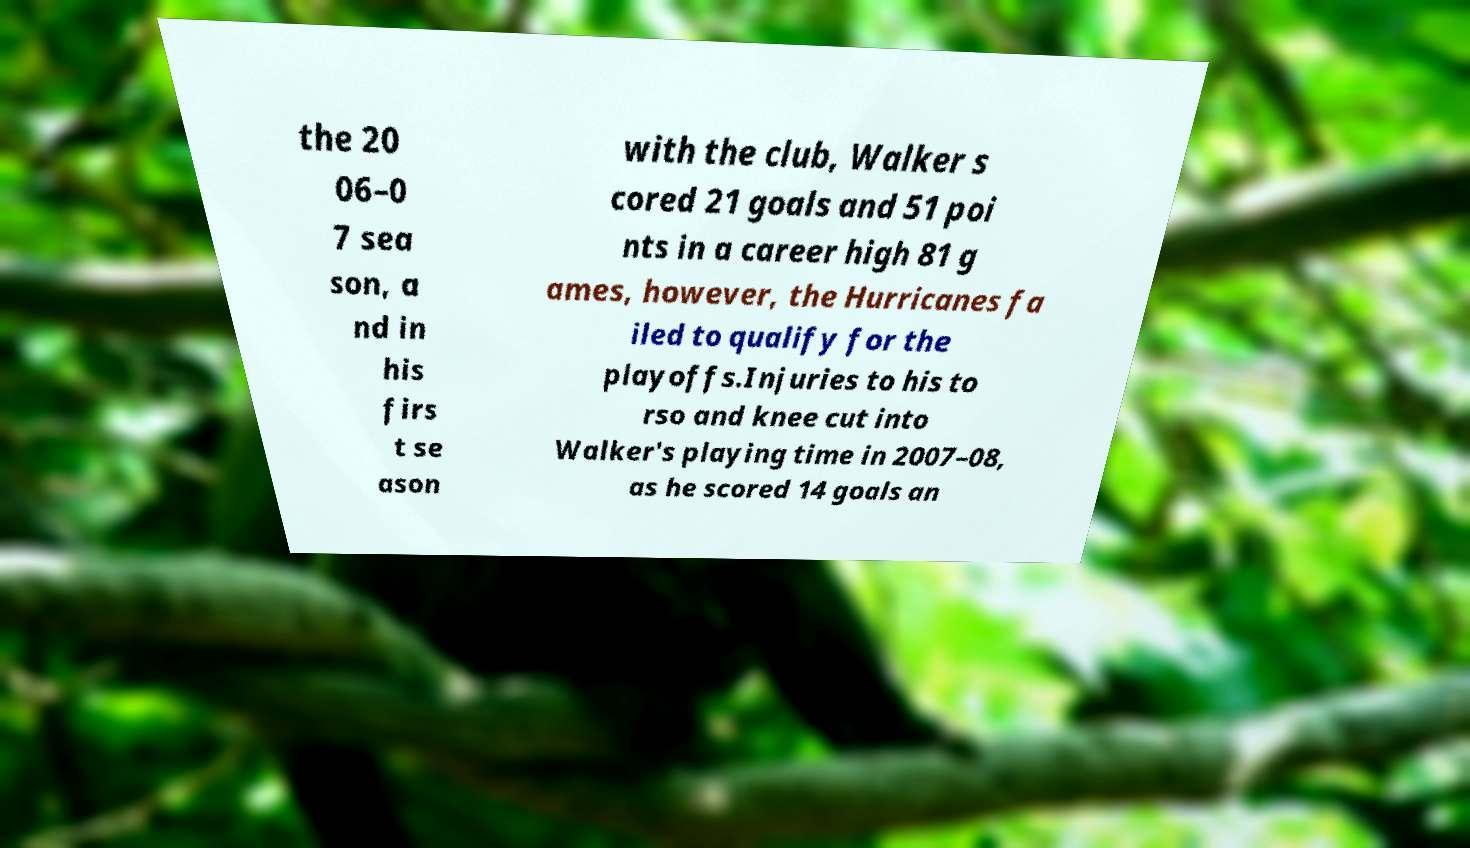For documentation purposes, I need the text within this image transcribed. Could you provide that? the 20 06–0 7 sea son, a nd in his firs t se ason with the club, Walker s cored 21 goals and 51 poi nts in a career high 81 g ames, however, the Hurricanes fa iled to qualify for the playoffs.Injuries to his to rso and knee cut into Walker's playing time in 2007–08, as he scored 14 goals an 